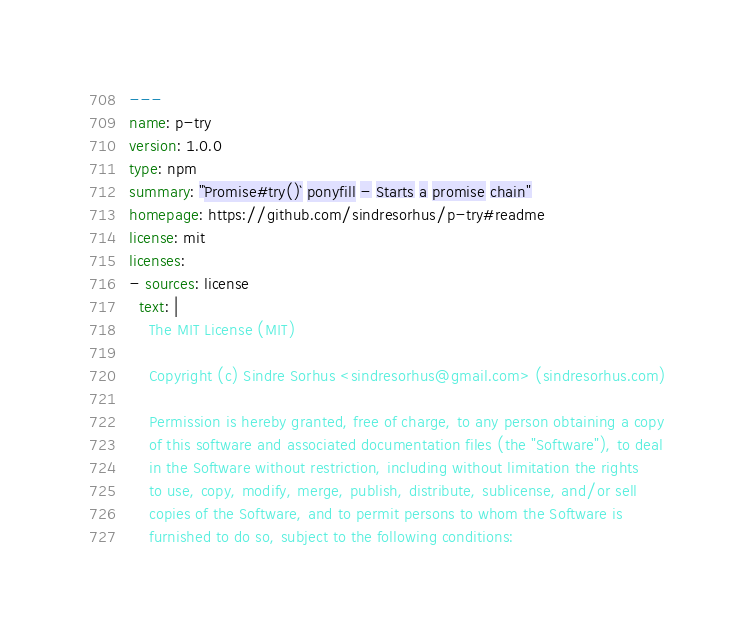Convert code to text. <code><loc_0><loc_0><loc_500><loc_500><_YAML_>---
name: p-try
version: 1.0.0
type: npm
summary: "`Promise#try()` ponyfill - Starts a promise chain"
homepage: https://github.com/sindresorhus/p-try#readme
license: mit
licenses:
- sources: license
  text: |
    The MIT License (MIT)

    Copyright (c) Sindre Sorhus <sindresorhus@gmail.com> (sindresorhus.com)

    Permission is hereby granted, free of charge, to any person obtaining a copy
    of this software and associated documentation files (the "Software"), to deal
    in the Software without restriction, including without limitation the rights
    to use, copy, modify, merge, publish, distribute, sublicense, and/or sell
    copies of the Software, and to permit persons to whom the Software is
    furnished to do so, subject to the following conditions:
</code> 